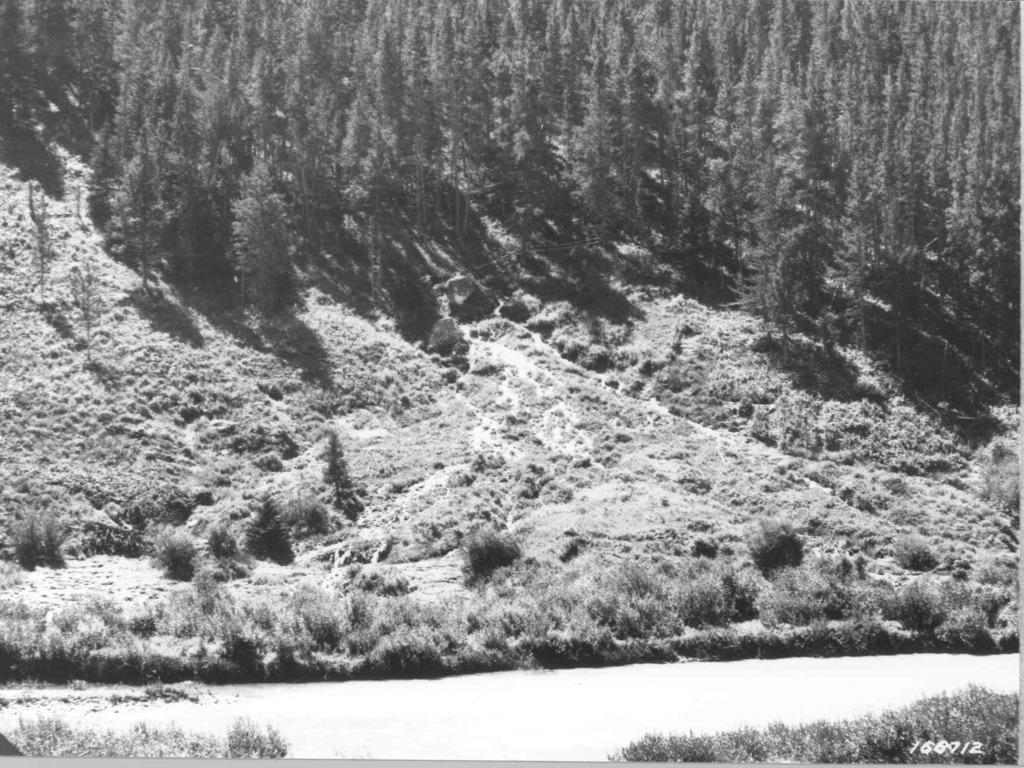Please provide a concise description of this image. In this black and white picture there is a hill having grass, plants and trees. Bottom of image there are few plants on land. 